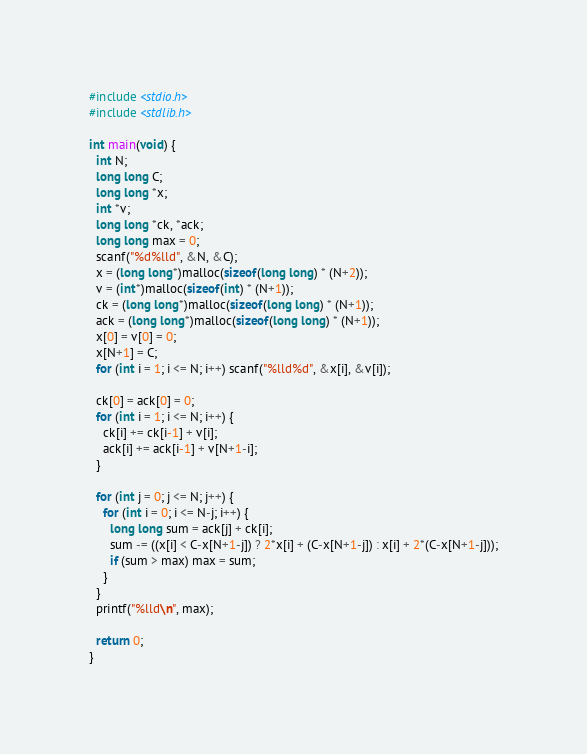<code> <loc_0><loc_0><loc_500><loc_500><_C_>#include <stdio.h>
#include <stdlib.h>

int main(void) {
  int N;
  long long C;
  long long *x;
  int *v;
  long long *ck, *ack;
  long long max = 0;
  scanf("%d%lld", &N, &C);
  x = (long long*)malloc(sizeof(long long) * (N+2));
  v = (int*)malloc(sizeof(int) * (N+1));
  ck = (long long*)malloc(sizeof(long long) * (N+1));
  ack = (long long*)malloc(sizeof(long long) * (N+1));
  x[0] = v[0] = 0;
  x[N+1] = C;
  for (int i = 1; i <= N; i++) scanf("%lld%d", &x[i], &v[i]);

  ck[0] = ack[0] = 0;
  for (int i = 1; i <= N; i++) {
    ck[i] += ck[i-1] + v[i];
    ack[i] += ack[i-1] + v[N+1-i];
  }

  for (int j = 0; j <= N; j++) {
    for (int i = 0; i <= N-j; i++) {
      long long sum = ack[j] + ck[i];
      sum -= ((x[i] < C-x[N+1-j]) ? 2*x[i] + (C-x[N+1-j]) : x[i] + 2*(C-x[N+1-j]));
      if (sum > max) max = sum;
    }
  }
  printf("%lld\n", max);

  return 0;
}</code> 